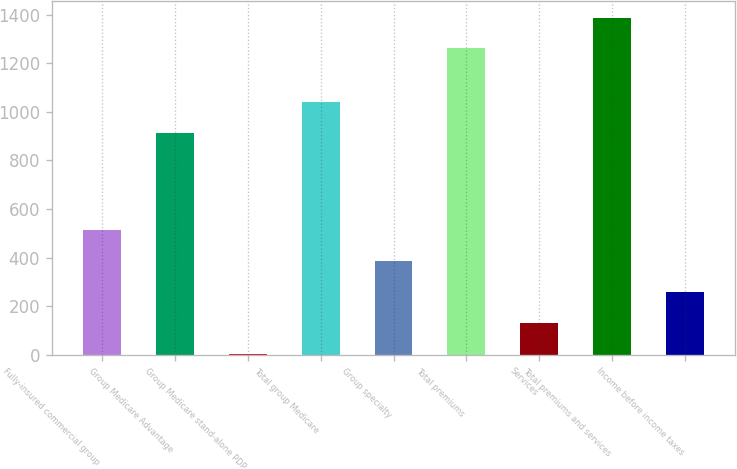Convert chart. <chart><loc_0><loc_0><loc_500><loc_500><bar_chart><fcel>Fully-insured commercial group<fcel>Group Medicare Advantage<fcel>Group Medicare stand-alone PDP<fcel>Total group Medicare<fcel>Group specialty<fcel>Total premiums<fcel>Services<fcel>Total premiums and services<fcel>Income before income taxes<nl><fcel>512.01<fcel>912<fcel>3.37<fcel>1039.16<fcel>384.85<fcel>1261<fcel>130.53<fcel>1388.16<fcel>257.69<nl></chart> 